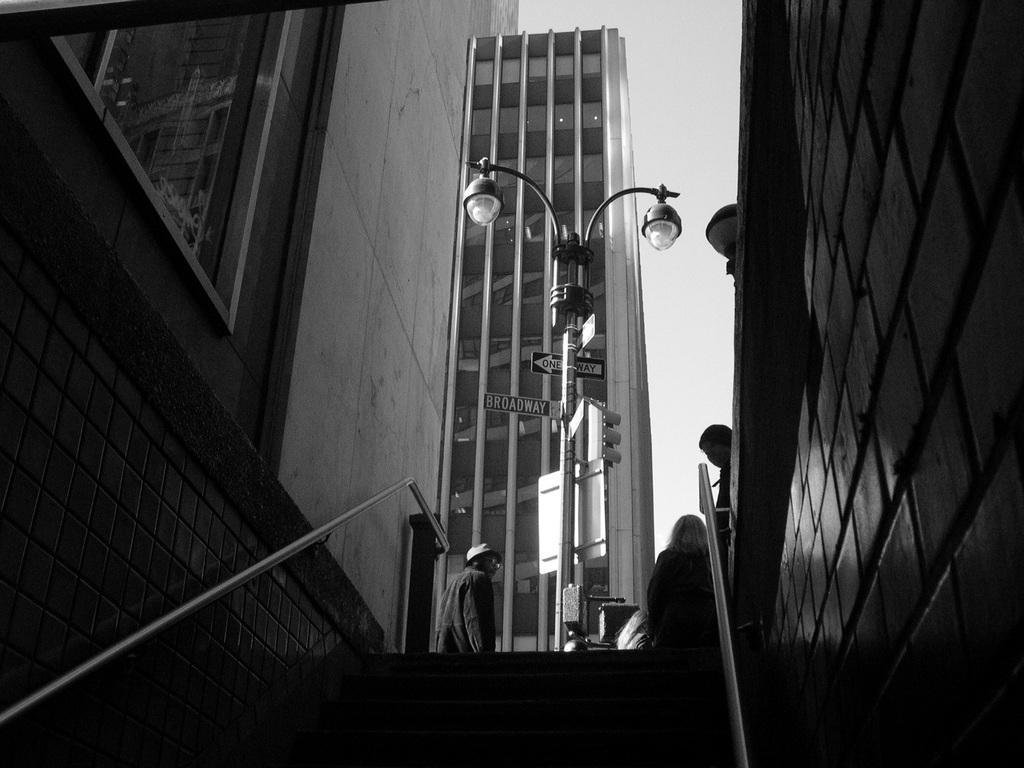In one or two sentences, can you explain what this image depicts? In this image I can see stairs in the centre and on the both side of it I can see railings. In the background I can see few buildings, few people, few poles, few boards and two street lights. I can also see this image is black and white in colour. 